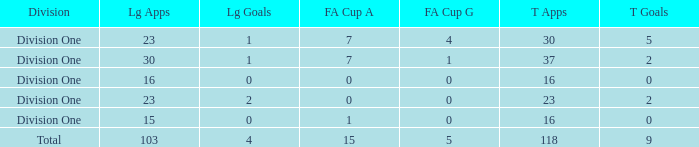It has a FA Cup Goals smaller than 4, and a FA Cup Apps larger than 7, what is the total number of total apps? 0.0. 